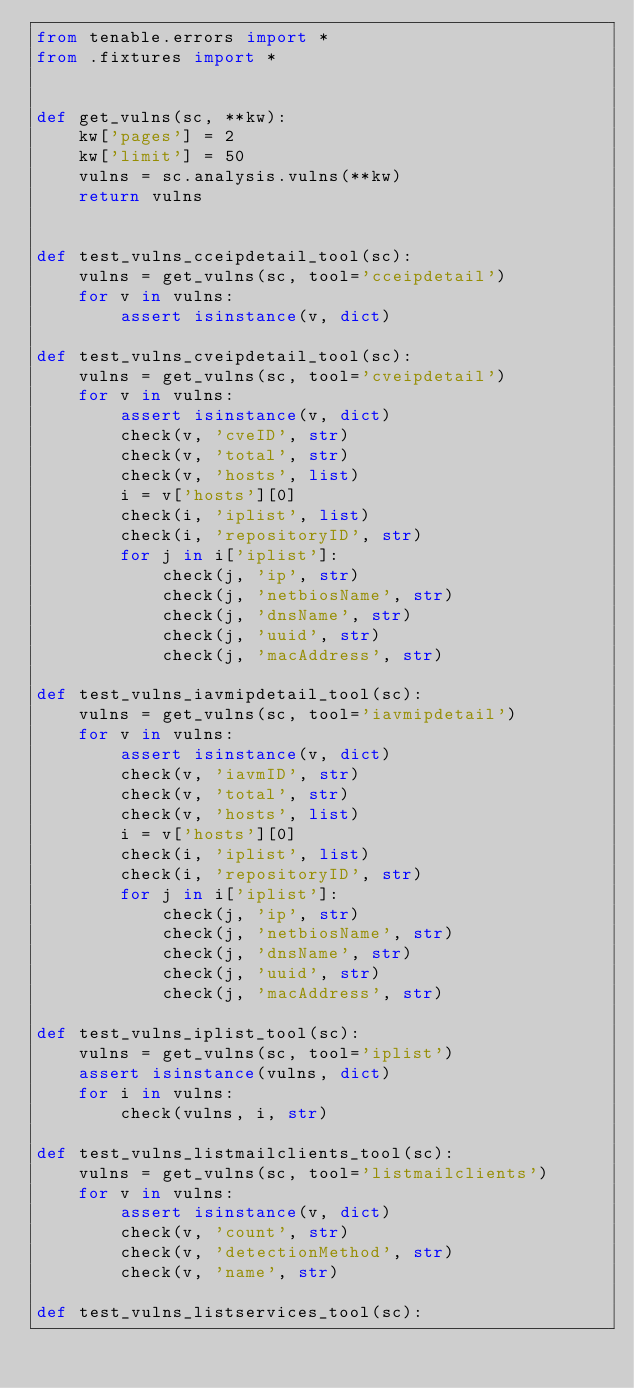Convert code to text. <code><loc_0><loc_0><loc_500><loc_500><_Python_>from tenable.errors import *
from .fixtures import *


def get_vulns(sc, **kw):
    kw['pages'] = 2
    kw['limit'] = 50
    vulns = sc.analysis.vulns(**kw)
    return vulns


def test_vulns_cceipdetail_tool(sc):
    vulns = get_vulns(sc, tool='cceipdetail')
    for v in vulns:
        assert isinstance(v, dict)

def test_vulns_cveipdetail_tool(sc):
    vulns = get_vulns(sc, tool='cveipdetail')
    for v in vulns:
        assert isinstance(v, dict)
        check(v, 'cveID', str)
        check(v, 'total', str)
        check(v, 'hosts', list)
        i = v['hosts'][0]
        check(i, 'iplist', list)
        check(i, 'repositoryID', str)
        for j in i['iplist']:
            check(j, 'ip', str)
            check(j, 'netbiosName', str)
            check(j, 'dnsName', str)
            check(j, 'uuid', str)
            check(j, 'macAddress', str)

def test_vulns_iavmipdetail_tool(sc):
    vulns = get_vulns(sc, tool='iavmipdetail')
    for v in vulns:
        assert isinstance(v, dict)
        check(v, 'iavmID', str)
        check(v, 'total', str)
        check(v, 'hosts', list)
        i = v['hosts'][0]
        check(i, 'iplist', list)
        check(i, 'repositoryID', str)
        for j in i['iplist']:
            check(j, 'ip', str)
            check(j, 'netbiosName', str)
            check(j, 'dnsName', str)
            check(j, 'uuid', str)
            check(j, 'macAddress', str)

def test_vulns_iplist_tool(sc):
    vulns = get_vulns(sc, tool='iplist')
    assert isinstance(vulns, dict)
    for i in vulns:
        check(vulns, i, str)

def test_vulns_listmailclients_tool(sc):
    vulns = get_vulns(sc, tool='listmailclients')
    for v in vulns:
        assert isinstance(v, dict)
        check(v, 'count', str)
        check(v, 'detectionMethod', str)
        check(v, 'name', str)

def test_vulns_listservices_tool(sc):</code> 